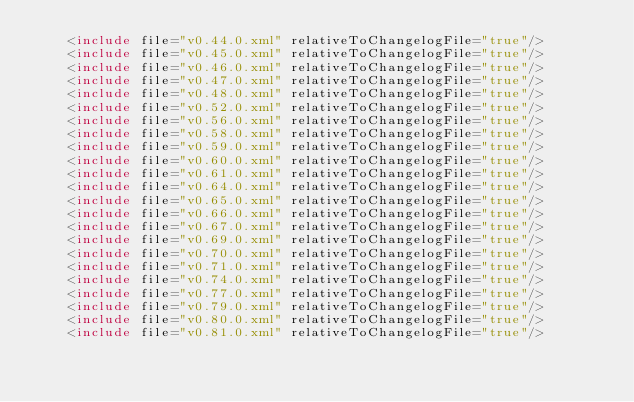Convert code to text. <code><loc_0><loc_0><loc_500><loc_500><_XML_>    <include file="v0.44.0.xml" relativeToChangelogFile="true"/>
    <include file="v0.45.0.xml" relativeToChangelogFile="true"/>
    <include file="v0.46.0.xml" relativeToChangelogFile="true"/>
    <include file="v0.47.0.xml" relativeToChangelogFile="true"/>
    <include file="v0.48.0.xml" relativeToChangelogFile="true"/>
    <include file="v0.52.0.xml" relativeToChangelogFile="true"/>
    <include file="v0.56.0.xml" relativeToChangelogFile="true"/>
    <include file="v0.58.0.xml" relativeToChangelogFile="true"/>
    <include file="v0.59.0.xml" relativeToChangelogFile="true"/>
    <include file="v0.60.0.xml" relativeToChangelogFile="true"/>
    <include file="v0.61.0.xml" relativeToChangelogFile="true"/>
    <include file="v0.64.0.xml" relativeToChangelogFile="true"/>
    <include file="v0.65.0.xml" relativeToChangelogFile="true"/>
    <include file="v0.66.0.xml" relativeToChangelogFile="true"/>
    <include file="v0.67.0.xml" relativeToChangelogFile="true"/>
    <include file="v0.69.0.xml" relativeToChangelogFile="true"/>
    <include file="v0.70.0.xml" relativeToChangelogFile="true"/>
    <include file="v0.71.0.xml" relativeToChangelogFile="true"/>
    <include file="v0.74.0.xml" relativeToChangelogFile="true"/>
    <include file="v0.77.0.xml" relativeToChangelogFile="true"/>
    <include file="v0.79.0.xml" relativeToChangelogFile="true"/>
    <include file="v0.80.0.xml" relativeToChangelogFile="true"/>
    <include file="v0.81.0.xml" relativeToChangelogFile="true"/></code> 